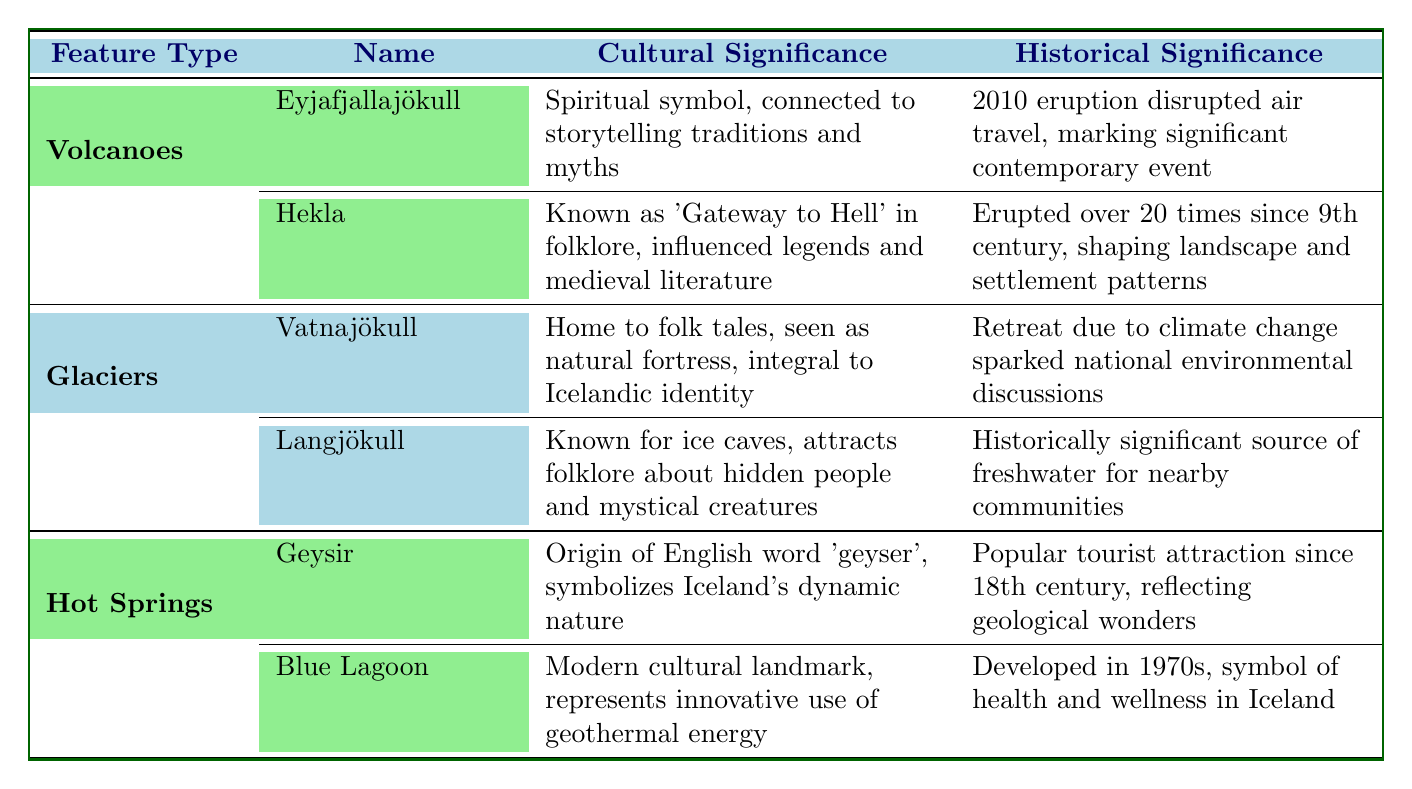What is the cultural significance of Eyjafjallajökull? The table states that Eyjafjallajökull is regarded as a spiritual symbol and is connected to storytelling traditions and myths in Icelandic culture.
Answer: Spiritual symbol, connected to storytelling traditions and myths What historical event is associated with the 2010 eruption of Eyjafjallajökull? The table mentions that the 2010 eruption disrupted air travel, marking a significant contemporary event in Iceland's history.
Answer: Disrupted air travel How many eruptions has Hekla had since the 9th century? According to the table, Hekla has erupted more than 20 times since the 9th century.
Answer: More than 20 times Which glacier is described as a natural fortress? The table indicates that Vatnajökull is seen as a natural fortress, which contributes to its cultural significance.
Answer: Vatnajökull True or False: The Blue Lagoon was developed in the 1970s. The table confirms that the Blue Lagoon was indeed developed in the 1970s, making this statement true.
Answer: True What is the average number of eruptions for Hekla and Eyjafjallajökull based on the data? Hekla has erupted more than 20 times, while Eyjafjallajökull has had one significant eruption in 2010. Since Hekla's data is given, we can take an average of more than 20 (for Hekla) and 1 (for Eyjafjallajökull), which is (20 + 1) / 2 = 10.5. This is a conceptual average since Hekla’s exact number is not specified.
Answer: 10.5 What are the cultural implications of the name "Geysir"? The table notes that Geysir is the origin of the English word for geyser and symbolizes Iceland's dynamic nature, indicating its cultural implications in shaping perceptions of natural wonders.
Answer: Origin of the English word for geyser, symbolizes dynamic nature What significant discussion has occurred due to the retreat of Vatnajökull? The table states that the retreat of Vatnajökull due to climate change has sparked national discussions on environmental conservation.
Answer: National discussions on environment and conservation How many geological feature types are listed in the table? The table lists three types of geological features: Volcanoes, Glaciers, and Hot Springs. Thus, the total count of feature types is three.
Answer: Three 